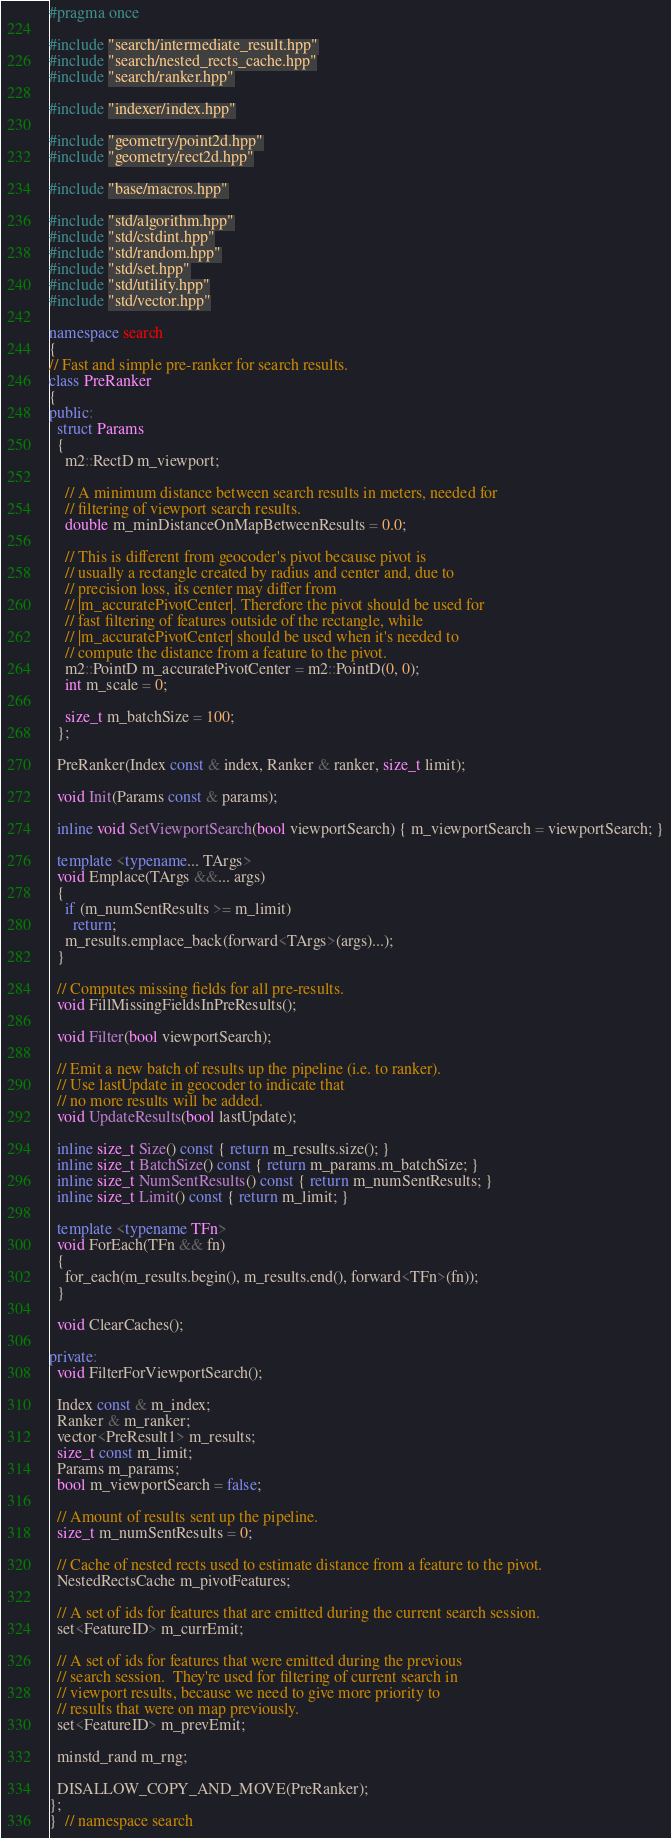Convert code to text. <code><loc_0><loc_0><loc_500><loc_500><_C++_>#pragma once

#include "search/intermediate_result.hpp"
#include "search/nested_rects_cache.hpp"
#include "search/ranker.hpp"

#include "indexer/index.hpp"

#include "geometry/point2d.hpp"
#include "geometry/rect2d.hpp"

#include "base/macros.hpp"

#include "std/algorithm.hpp"
#include "std/cstdint.hpp"
#include "std/random.hpp"
#include "std/set.hpp"
#include "std/utility.hpp"
#include "std/vector.hpp"

namespace search
{
// Fast and simple pre-ranker for search results.
class PreRanker
{
public:
  struct Params
  {
    m2::RectD m_viewport;

    // A minimum distance between search results in meters, needed for
    // filtering of viewport search results.
    double m_minDistanceOnMapBetweenResults = 0.0;

    // This is different from geocoder's pivot because pivot is
    // usually a rectangle created by radius and center and, due to
    // precision loss, its center may differ from
    // |m_accuratePivotCenter|. Therefore the pivot should be used for
    // fast filtering of features outside of the rectangle, while
    // |m_accuratePivotCenter| should be used when it's needed to
    // compute the distance from a feature to the pivot.
    m2::PointD m_accuratePivotCenter = m2::PointD(0, 0);
    int m_scale = 0;

    size_t m_batchSize = 100;
  };

  PreRanker(Index const & index, Ranker & ranker, size_t limit);

  void Init(Params const & params);

  inline void SetViewportSearch(bool viewportSearch) { m_viewportSearch = viewportSearch; }

  template <typename... TArgs>
  void Emplace(TArgs &&... args)
  {
    if (m_numSentResults >= m_limit)
      return;
    m_results.emplace_back(forward<TArgs>(args)...);
  }

  // Computes missing fields for all pre-results.
  void FillMissingFieldsInPreResults();

  void Filter(bool viewportSearch);

  // Emit a new batch of results up the pipeline (i.e. to ranker).
  // Use lastUpdate in geocoder to indicate that
  // no more results will be added.
  void UpdateResults(bool lastUpdate);

  inline size_t Size() const { return m_results.size(); }
  inline size_t BatchSize() const { return m_params.m_batchSize; }
  inline size_t NumSentResults() const { return m_numSentResults; }
  inline size_t Limit() const { return m_limit; }

  template <typename TFn>
  void ForEach(TFn && fn)
  {
    for_each(m_results.begin(), m_results.end(), forward<TFn>(fn));
  }

  void ClearCaches();

private:
  void FilterForViewportSearch();

  Index const & m_index;
  Ranker & m_ranker;
  vector<PreResult1> m_results;
  size_t const m_limit;
  Params m_params;
  bool m_viewportSearch = false;

  // Amount of results sent up the pipeline.
  size_t m_numSentResults = 0;

  // Cache of nested rects used to estimate distance from a feature to the pivot.
  NestedRectsCache m_pivotFeatures;

  // A set of ids for features that are emitted during the current search session.
  set<FeatureID> m_currEmit;

  // A set of ids for features that were emitted during the previous
  // search session.  They're used for filtering of current search in
  // viewport results, because we need to give more priority to
  // results that were on map previously.
  set<FeatureID> m_prevEmit;

  minstd_rand m_rng;

  DISALLOW_COPY_AND_MOVE(PreRanker);
};
}  // namespace search
</code> 